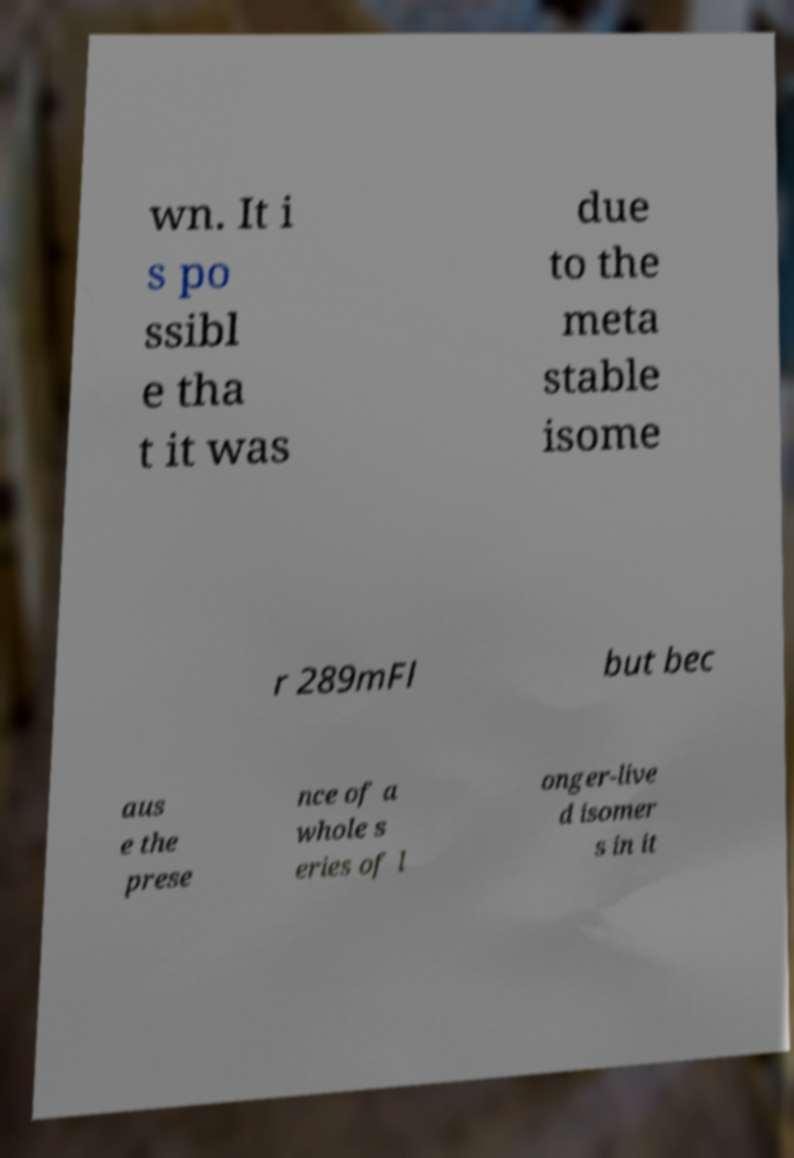I need the written content from this picture converted into text. Can you do that? wn. It i s po ssibl e tha t it was due to the meta stable isome r 289mFl but bec aus e the prese nce of a whole s eries of l onger-live d isomer s in it 